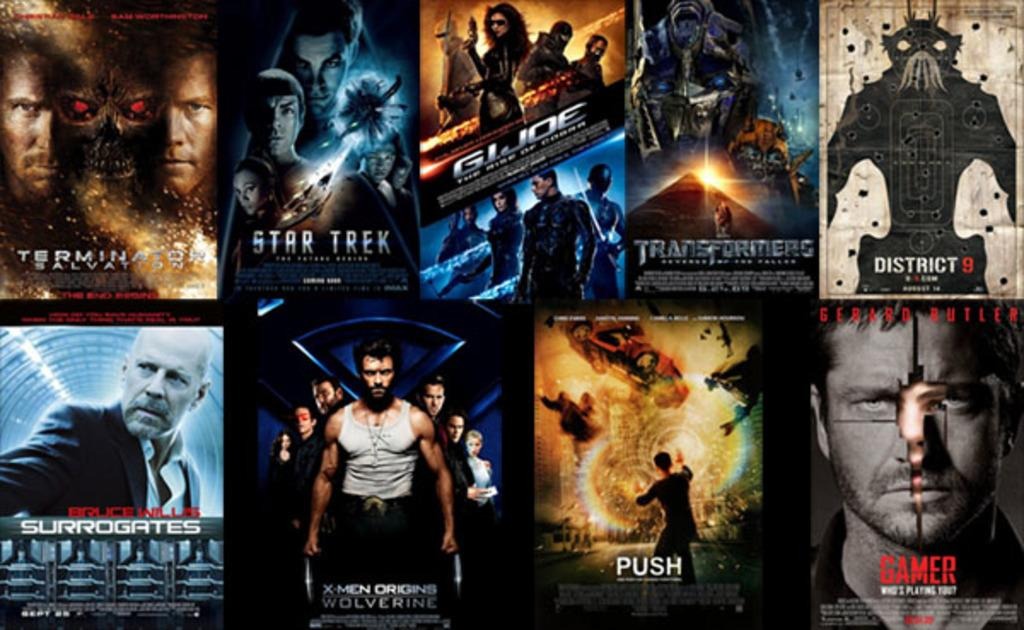What type of artwork is depicted in the image? The image is a collage. What can be seen within the collage? There are people and names in the collage. Can you describe any other elements present in the collage? There are other unspecified elements in the collage. What color is the crayon used to draw the bubble in the image? There is no crayon or bubble present in the image, as it is a collage consisting of people, names, and other unspecified elements. 